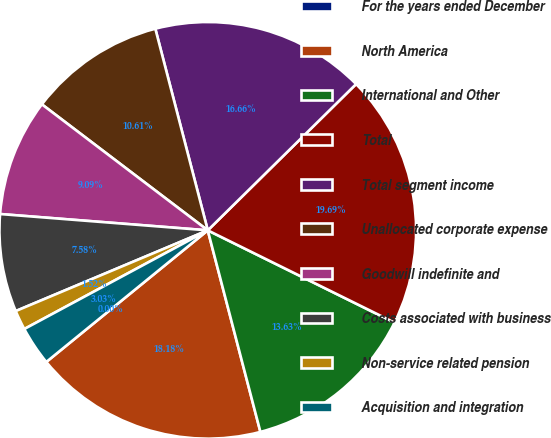Convert chart to OTSL. <chart><loc_0><loc_0><loc_500><loc_500><pie_chart><fcel>For the years ended December<fcel>North America<fcel>International and Other<fcel>Total<fcel>Total segment income<fcel>Unallocated corporate expense<fcel>Goodwill indefinite and<fcel>Costs associated with business<fcel>Non-service related pension<fcel>Acquisition and integration<nl><fcel>0.0%<fcel>18.18%<fcel>13.63%<fcel>19.69%<fcel>16.66%<fcel>10.61%<fcel>9.09%<fcel>7.58%<fcel>1.52%<fcel>3.03%<nl></chart> 